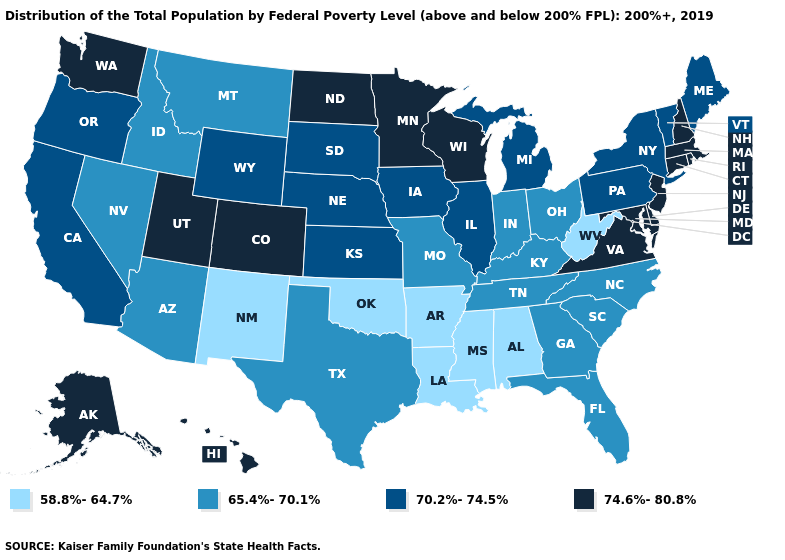Among the states that border Arizona , does Colorado have the lowest value?
Quick response, please. No. Name the states that have a value in the range 65.4%-70.1%?
Quick response, please. Arizona, Florida, Georgia, Idaho, Indiana, Kentucky, Missouri, Montana, Nevada, North Carolina, Ohio, South Carolina, Tennessee, Texas. Which states have the highest value in the USA?
Write a very short answer. Alaska, Colorado, Connecticut, Delaware, Hawaii, Maryland, Massachusetts, Minnesota, New Hampshire, New Jersey, North Dakota, Rhode Island, Utah, Virginia, Washington, Wisconsin. Among the states that border Alabama , which have the highest value?
Be succinct. Florida, Georgia, Tennessee. Name the states that have a value in the range 58.8%-64.7%?
Answer briefly. Alabama, Arkansas, Louisiana, Mississippi, New Mexico, Oklahoma, West Virginia. What is the value of Oregon?
Concise answer only. 70.2%-74.5%. What is the value of Massachusetts?
Quick response, please. 74.6%-80.8%. What is the highest value in states that border Nevada?
Give a very brief answer. 74.6%-80.8%. Which states have the lowest value in the USA?
Answer briefly. Alabama, Arkansas, Louisiana, Mississippi, New Mexico, Oklahoma, West Virginia. What is the lowest value in the South?
Concise answer only. 58.8%-64.7%. What is the value of Georgia?
Answer briefly. 65.4%-70.1%. What is the value of Colorado?
Short answer required. 74.6%-80.8%. What is the lowest value in the USA?
Be succinct. 58.8%-64.7%. What is the value of Kansas?
Quick response, please. 70.2%-74.5%. Does Virginia have the same value as Rhode Island?
Quick response, please. Yes. 